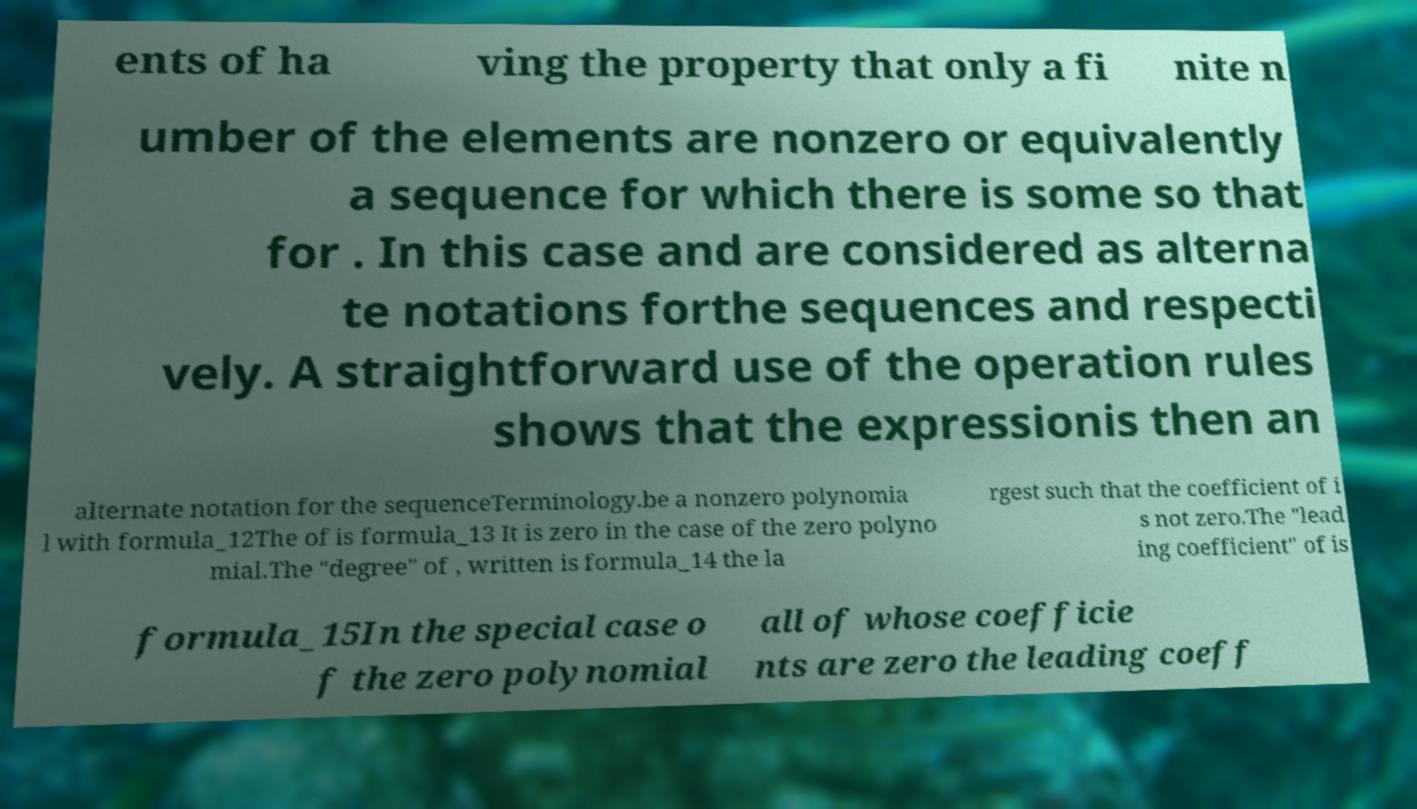Could you assist in decoding the text presented in this image and type it out clearly? ents of ha ving the property that only a fi nite n umber of the elements are nonzero or equivalently a sequence for which there is some so that for . In this case and are considered as alterna te notations forthe sequences and respecti vely. A straightforward use of the operation rules shows that the expressionis then an alternate notation for the sequenceTerminology.be a nonzero polynomia l with formula_12The of is formula_13 It is zero in the case of the zero polyno mial.The "degree" of , written is formula_14 the la rgest such that the coefficient of i s not zero.The "lead ing coefficient" of is formula_15In the special case o f the zero polynomial all of whose coefficie nts are zero the leading coeff 